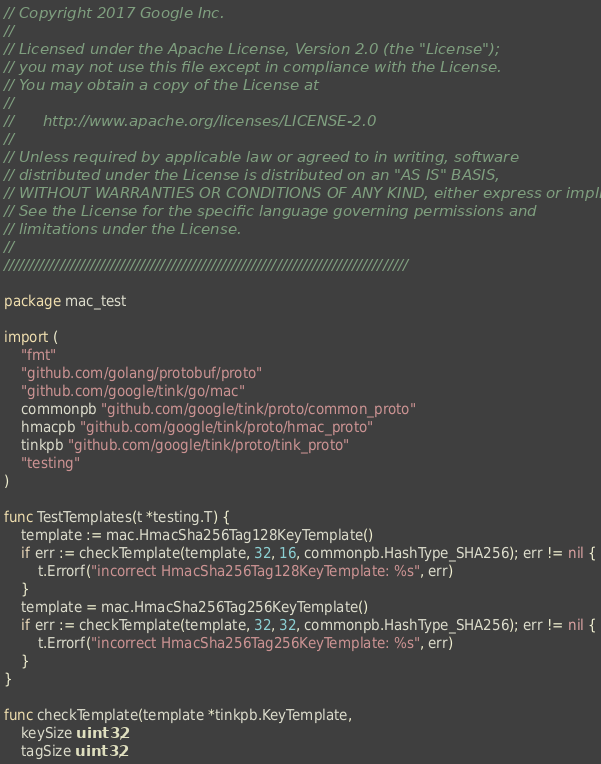Convert code to text. <code><loc_0><loc_0><loc_500><loc_500><_Go_>// Copyright 2017 Google Inc.
//
// Licensed under the Apache License, Version 2.0 (the "License");
// you may not use this file except in compliance with the License.
// You may obtain a copy of the License at
//
//      http://www.apache.org/licenses/LICENSE-2.0
//
// Unless required by applicable law or agreed to in writing, software
// distributed under the License is distributed on an "AS IS" BASIS,
// WITHOUT WARRANTIES OR CONDITIONS OF ANY KIND, either express or implied.
// See the License for the specific language governing permissions and
// limitations under the License.
//
////////////////////////////////////////////////////////////////////////////////

package mac_test

import (
	"fmt"
	"github.com/golang/protobuf/proto"
	"github.com/google/tink/go/mac"
	commonpb "github.com/google/tink/proto/common_proto"
	hmacpb "github.com/google/tink/proto/hmac_proto"
	tinkpb "github.com/google/tink/proto/tink_proto"
	"testing"
)

func TestTemplates(t *testing.T) {
	template := mac.HmacSha256Tag128KeyTemplate()
	if err := checkTemplate(template, 32, 16, commonpb.HashType_SHA256); err != nil {
		t.Errorf("incorrect HmacSha256Tag128KeyTemplate: %s", err)
	}
	template = mac.HmacSha256Tag256KeyTemplate()
	if err := checkTemplate(template, 32, 32, commonpb.HashType_SHA256); err != nil {
		t.Errorf("incorrect HmacSha256Tag256KeyTemplate: %s", err)
	}
}

func checkTemplate(template *tinkpb.KeyTemplate,
	keySize uint32,
	tagSize uint32,</code> 